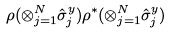<formula> <loc_0><loc_0><loc_500><loc_500>\rho ( \otimes ^ { N } _ { j = 1 } \hat { \sigma } ^ { y } _ { j } ) \rho ^ { * } ( \otimes ^ { N } _ { j = 1 } \hat { \sigma } ^ { y } _ { j } )</formula> 